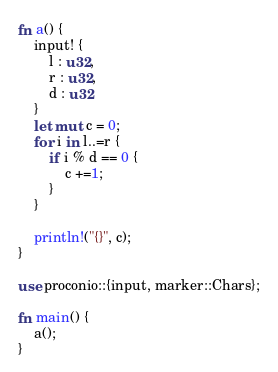Convert code to text. <code><loc_0><loc_0><loc_500><loc_500><_Rust_>fn a() {
    input! {
        l : u32,
        r : u32,
        d : u32
    }
    let mut c = 0;
    for i in l..=r {
        if i % d == 0 {
            c +=1;
        }
    }

    println!("{}", c);
}

use proconio::{input, marker::Chars};

fn main() {
    a();
}</code> 